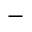Convert formula to latex. <formula><loc_0><loc_0><loc_500><loc_500>-</formula> 